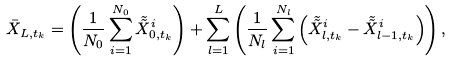<formula> <loc_0><loc_0><loc_500><loc_500>\bar { X } _ { L , t _ { k } } = \left ( \frac { 1 } { N _ { 0 } } \sum ^ { N _ { 0 } } _ { i = 1 } \tilde { \tilde { X } } _ { 0 , t _ { k } } ^ { i } \right ) + \sum ^ { L } _ { l = 1 } \left ( \frac { 1 } { N _ { l } } \sum ^ { N _ { l } } _ { i = 1 } \left ( \tilde { \tilde { X } } _ { l , t _ { k } } ^ { i } - \tilde { \tilde { X } } _ { l - 1 , t _ { k } } ^ { i } \right ) \right ) ,</formula> 